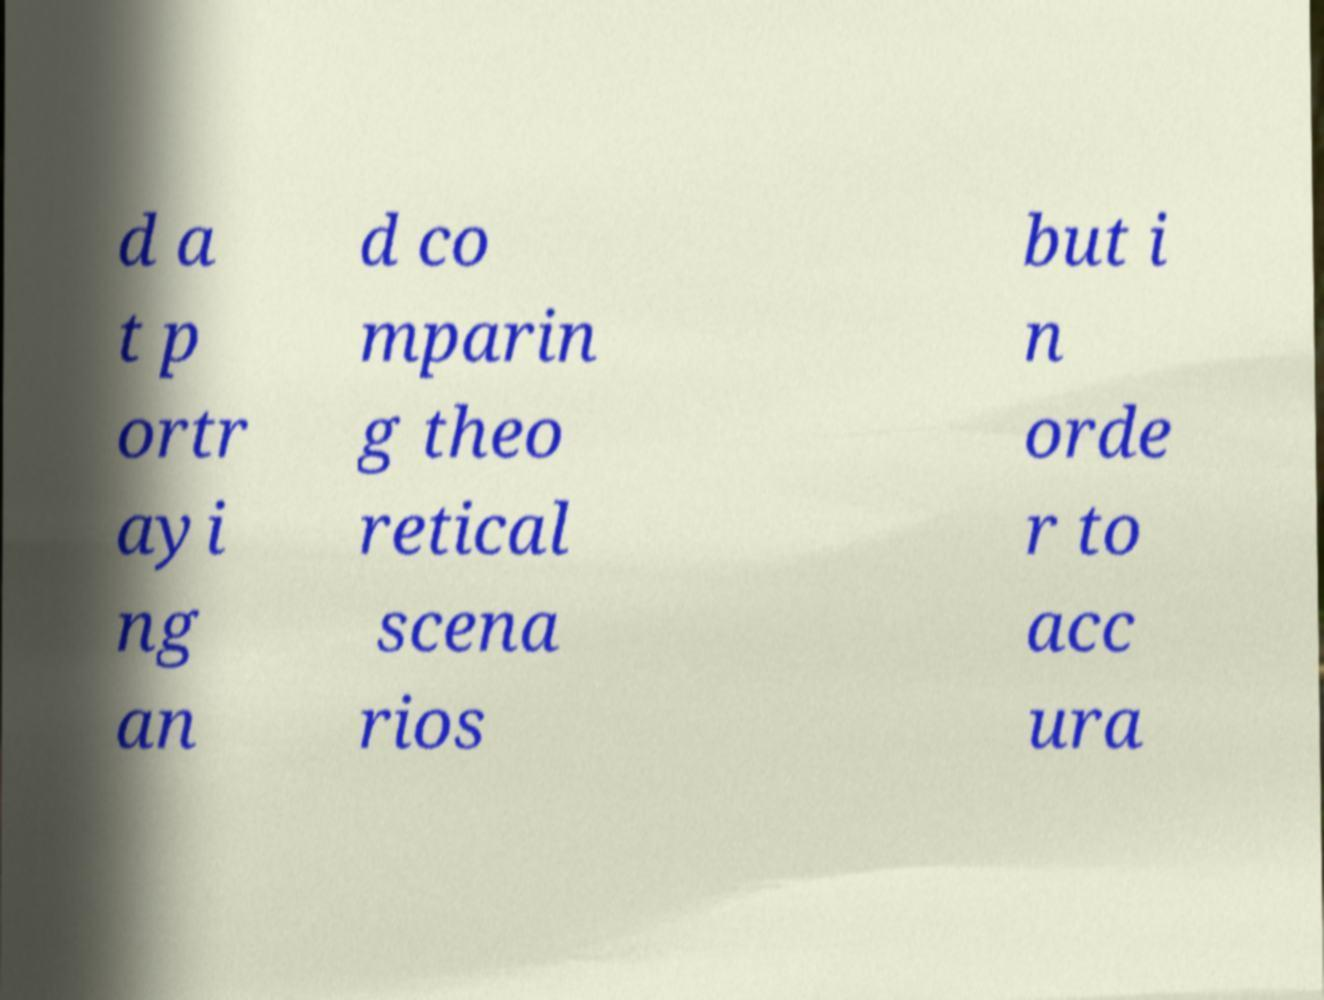There's text embedded in this image that I need extracted. Can you transcribe it verbatim? d a t p ortr ayi ng an d co mparin g theo retical scena rios but i n orde r to acc ura 